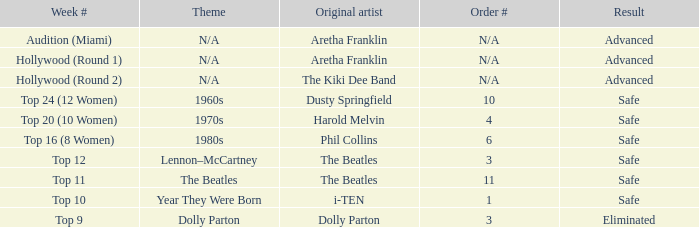What is the order number that has top 20 (10 women)  as the week number? 4.0. 